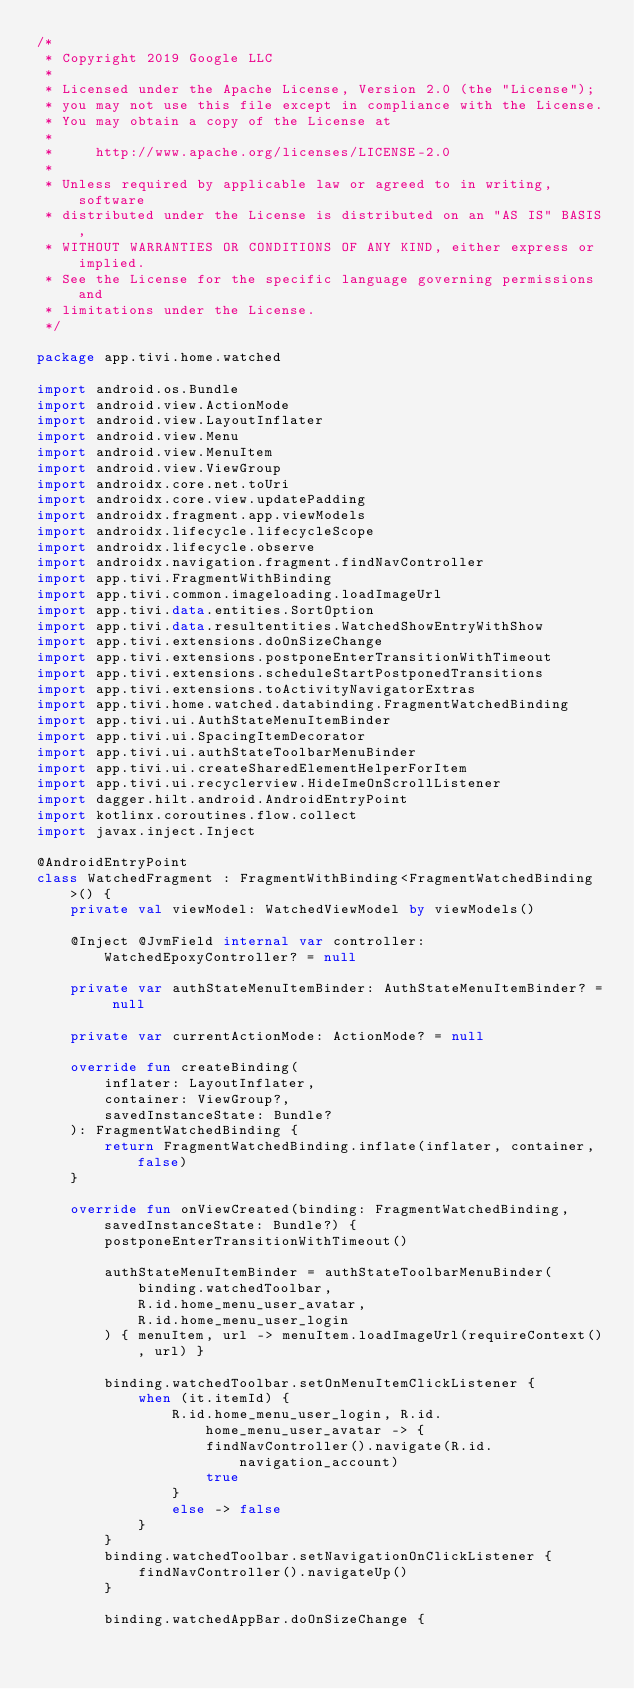<code> <loc_0><loc_0><loc_500><loc_500><_Kotlin_>/*
 * Copyright 2019 Google LLC
 *
 * Licensed under the Apache License, Version 2.0 (the "License");
 * you may not use this file except in compliance with the License.
 * You may obtain a copy of the License at
 *
 *     http://www.apache.org/licenses/LICENSE-2.0
 *
 * Unless required by applicable law or agreed to in writing, software
 * distributed under the License is distributed on an "AS IS" BASIS,
 * WITHOUT WARRANTIES OR CONDITIONS OF ANY KIND, either express or implied.
 * See the License for the specific language governing permissions and
 * limitations under the License.
 */

package app.tivi.home.watched

import android.os.Bundle
import android.view.ActionMode
import android.view.LayoutInflater
import android.view.Menu
import android.view.MenuItem
import android.view.ViewGroup
import androidx.core.net.toUri
import androidx.core.view.updatePadding
import androidx.fragment.app.viewModels
import androidx.lifecycle.lifecycleScope
import androidx.lifecycle.observe
import androidx.navigation.fragment.findNavController
import app.tivi.FragmentWithBinding
import app.tivi.common.imageloading.loadImageUrl
import app.tivi.data.entities.SortOption
import app.tivi.data.resultentities.WatchedShowEntryWithShow
import app.tivi.extensions.doOnSizeChange
import app.tivi.extensions.postponeEnterTransitionWithTimeout
import app.tivi.extensions.scheduleStartPostponedTransitions
import app.tivi.extensions.toActivityNavigatorExtras
import app.tivi.home.watched.databinding.FragmentWatchedBinding
import app.tivi.ui.AuthStateMenuItemBinder
import app.tivi.ui.SpacingItemDecorator
import app.tivi.ui.authStateToolbarMenuBinder
import app.tivi.ui.createSharedElementHelperForItem
import app.tivi.ui.recyclerview.HideImeOnScrollListener
import dagger.hilt.android.AndroidEntryPoint
import kotlinx.coroutines.flow.collect
import javax.inject.Inject

@AndroidEntryPoint
class WatchedFragment : FragmentWithBinding<FragmentWatchedBinding>() {
    private val viewModel: WatchedViewModel by viewModels()

    @Inject @JvmField internal var controller: WatchedEpoxyController? = null

    private var authStateMenuItemBinder: AuthStateMenuItemBinder? = null

    private var currentActionMode: ActionMode? = null

    override fun createBinding(
        inflater: LayoutInflater,
        container: ViewGroup?,
        savedInstanceState: Bundle?
    ): FragmentWatchedBinding {
        return FragmentWatchedBinding.inflate(inflater, container, false)
    }

    override fun onViewCreated(binding: FragmentWatchedBinding, savedInstanceState: Bundle?) {
        postponeEnterTransitionWithTimeout()

        authStateMenuItemBinder = authStateToolbarMenuBinder(
            binding.watchedToolbar,
            R.id.home_menu_user_avatar,
            R.id.home_menu_user_login
        ) { menuItem, url -> menuItem.loadImageUrl(requireContext(), url) }

        binding.watchedToolbar.setOnMenuItemClickListener {
            when (it.itemId) {
                R.id.home_menu_user_login, R.id.home_menu_user_avatar -> {
                    findNavController().navigate(R.id.navigation_account)
                    true
                }
                else -> false
            }
        }
        binding.watchedToolbar.setNavigationOnClickListener {
            findNavController().navigateUp()
        }

        binding.watchedAppBar.doOnSizeChange {</code> 